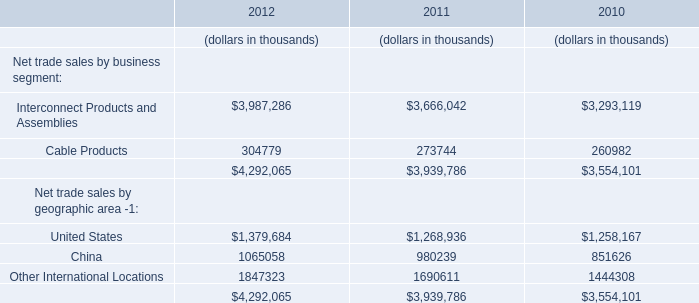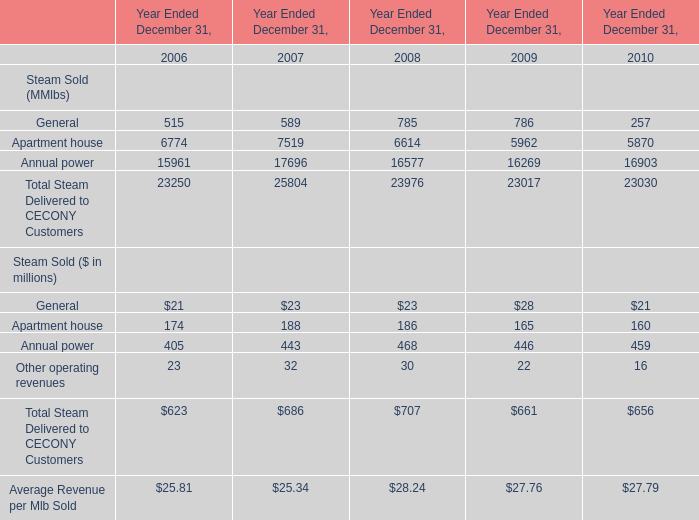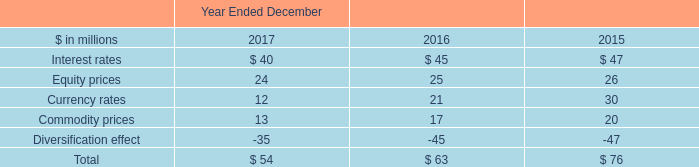What is the average value of Annual power for Steam Sold (MMlbs) and Cable Products for Net trade sales by business segment in 2010? (in million) 
Computations: ((16903 + 260982) / 2)
Answer: 138942.5. 